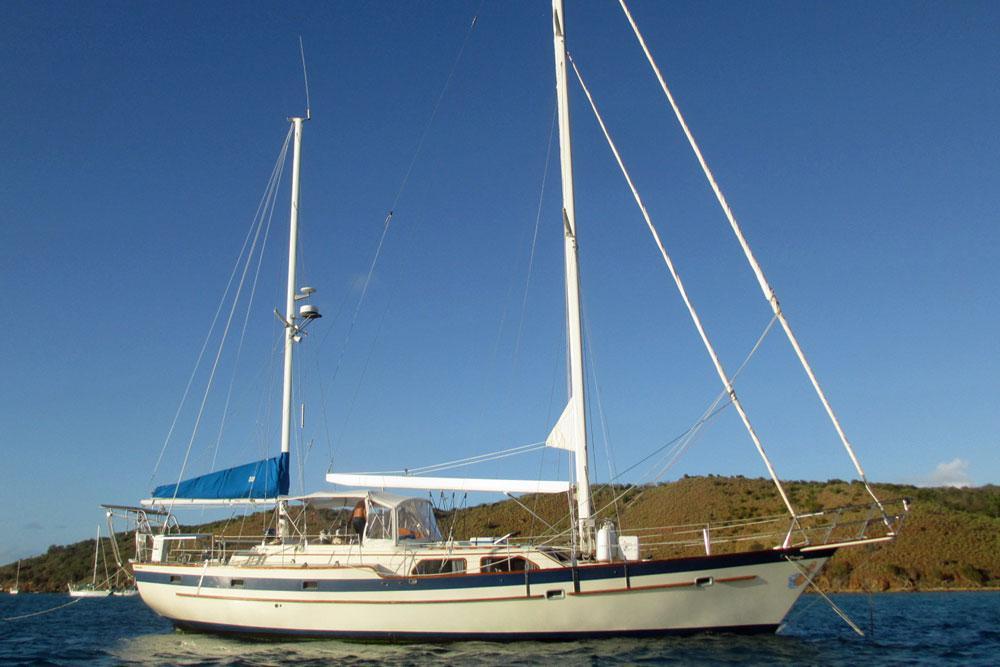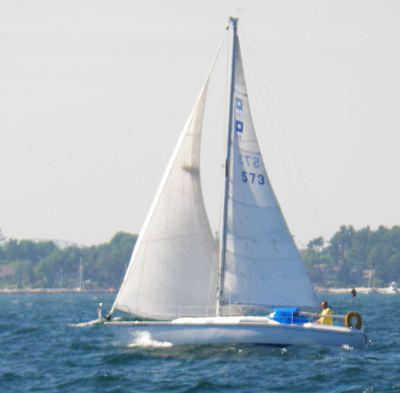The first image is the image on the left, the second image is the image on the right. Assess this claim about the two images: "All the boats have their sails up.". Correct or not? Answer yes or no. No. The first image is the image on the left, the second image is the image on the right. Given the left and right images, does the statement "The sails are down on at least one of the vessels." hold true? Answer yes or no. Yes. 